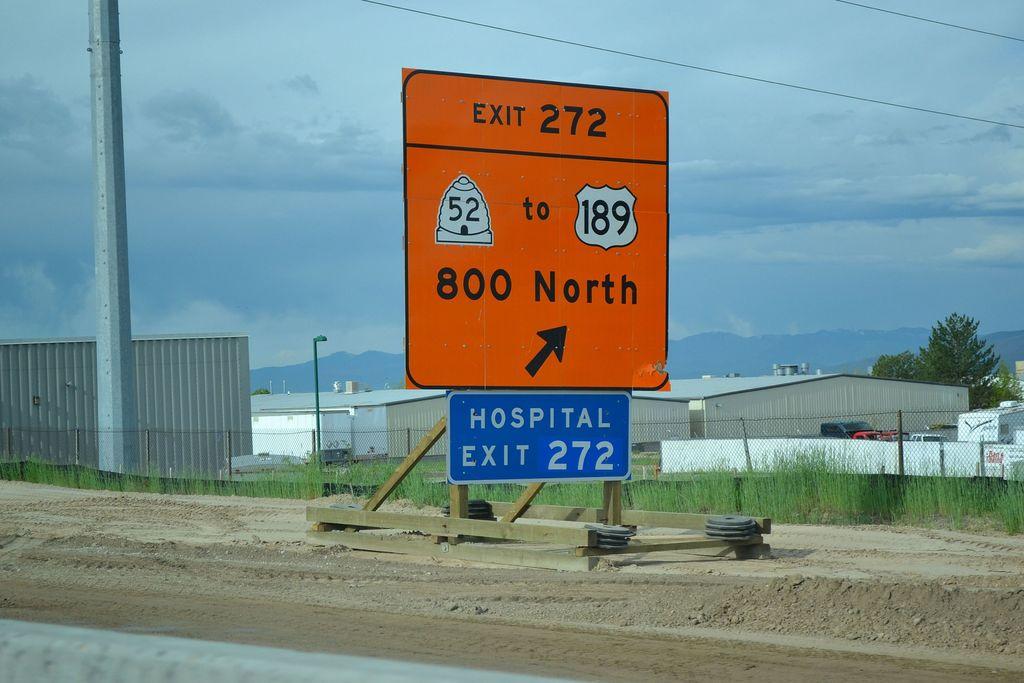What exit is the hospital on?
Your answer should be very brief. 272. How far north?
Offer a very short reply. 800. 